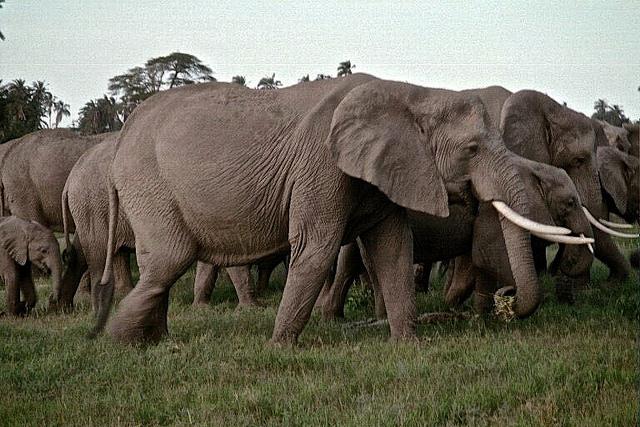Is the elephant's tusk touching anything?
Keep it brief. No. Are they all the same size?
Quick response, please. No. What animals are these?
Answer briefly. Elephants. How many elephants are in the photo?
Write a very short answer. 6. Was the photographer on safari?
Write a very short answer. Yes. Why is the picture taken far away from the elephant?
Short answer required. Danger. How many elephants are there?
Answer briefly. 5. What are the elephants doing?
Write a very short answer. Walking. How many elephants are in the picture?
Be succinct. 10. How many elephants do you see?
Answer briefly. 6. Is there a baby elephant shown?
Keep it brief. Yes. What is the color of the elephants?
Answer briefly. Gray. 